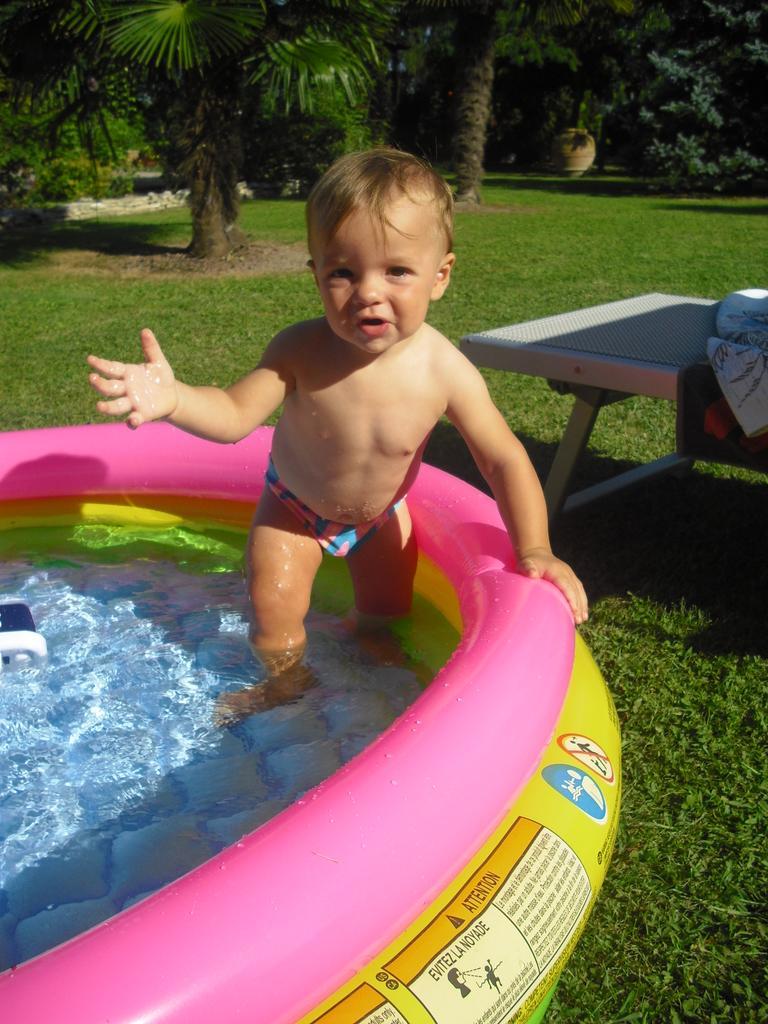How would you summarize this image in a sentence or two? In the middle of the image a kid is standing and smiling. Bottom left side of the image there is a water balloon. Bottom right side of the image there is grass and there is a table. At the top of the image there are some trees and plants. 